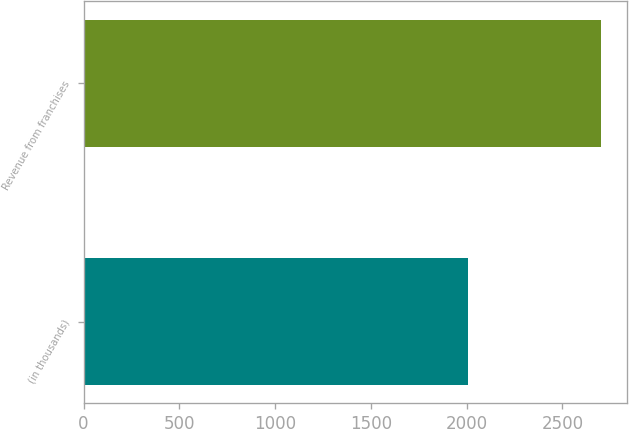Convert chart to OTSL. <chart><loc_0><loc_0><loc_500><loc_500><bar_chart><fcel>(in thousands)<fcel>Revenue from franchises<nl><fcel>2007<fcel>2704<nl></chart> 